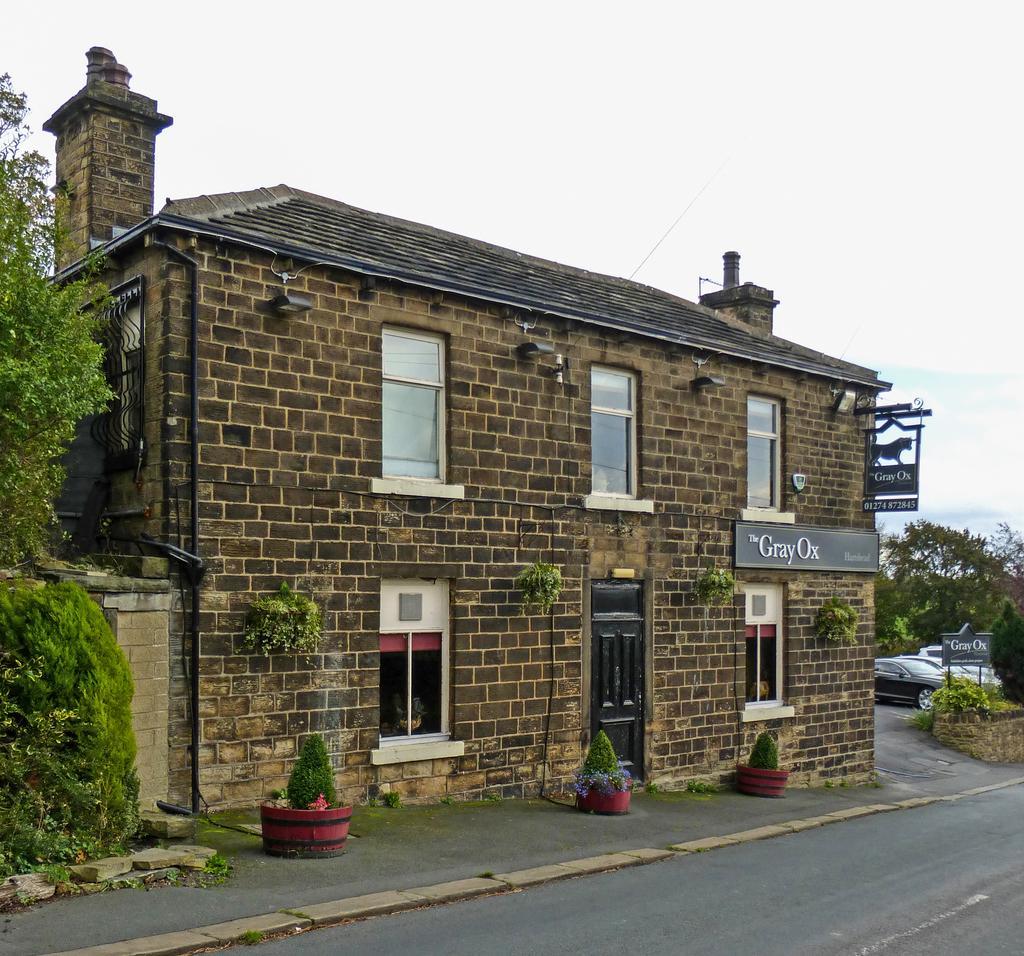How would you summarize this image in a sentence or two? In this picture I can observe a building in the middle of the picture. In front of the building there is a road. On the right side I can observe cars parked in the parking lot. In the background there is sky. 